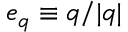<formula> <loc_0><loc_0><loc_500><loc_500>e _ { q } \equiv q / | { \boldsymbol q } |</formula> 